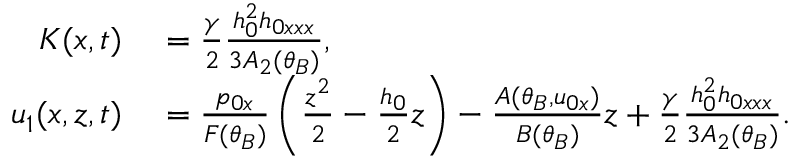Convert formula to latex. <formula><loc_0><loc_0><loc_500><loc_500>\begin{array} { r l } { K ( x , t ) } & = \frac { \gamma } { 2 } \frac { h _ { 0 } ^ { 2 } h _ { 0 x x x } } { 3 A _ { 2 } ( \theta _ { B } ) } , } \\ { u _ { 1 } ( x , z , t ) } & = \frac { p _ { 0 x } } { F ( \theta _ { B } ) } \left ( \frac { z ^ { 2 } } { 2 } - \frac { h _ { 0 } } { 2 } z \right ) - \frac { A ( \theta _ { B } , u _ { 0 x } ) } { B ( \theta _ { B } ) } z + \frac { \gamma } { 2 } \frac { h _ { 0 } ^ { 2 } h _ { 0 x x x } } { 3 A _ { 2 } ( \theta _ { B } ) } . } \end{array}</formula> 